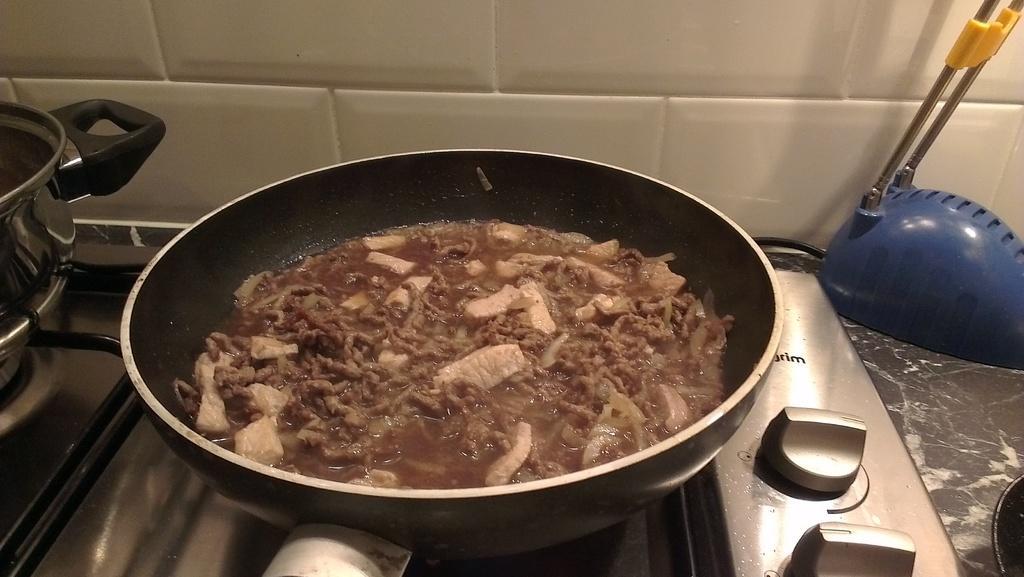Describe this image in one or two sentences. In this image, we can see food in the pan and there is a container on the stove. In the background, there is an object and we can see a pan on the table and there is a wall. 